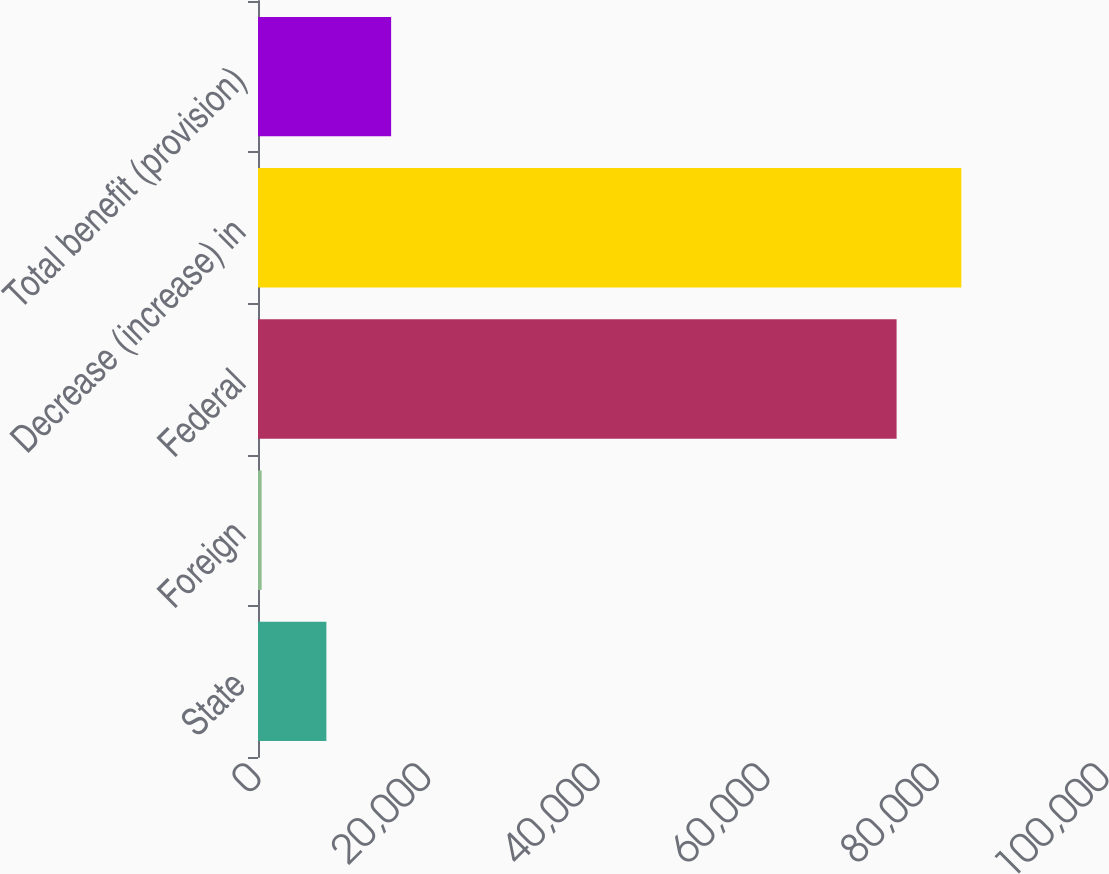<chart> <loc_0><loc_0><loc_500><loc_500><bar_chart><fcel>State<fcel>Foreign<fcel>Federal<fcel>Decrease (increase) in<fcel>Total benefit (provision)<nl><fcel>8063.7<fcel>428<fcel>75306<fcel>82941.7<fcel>15699.4<nl></chart> 